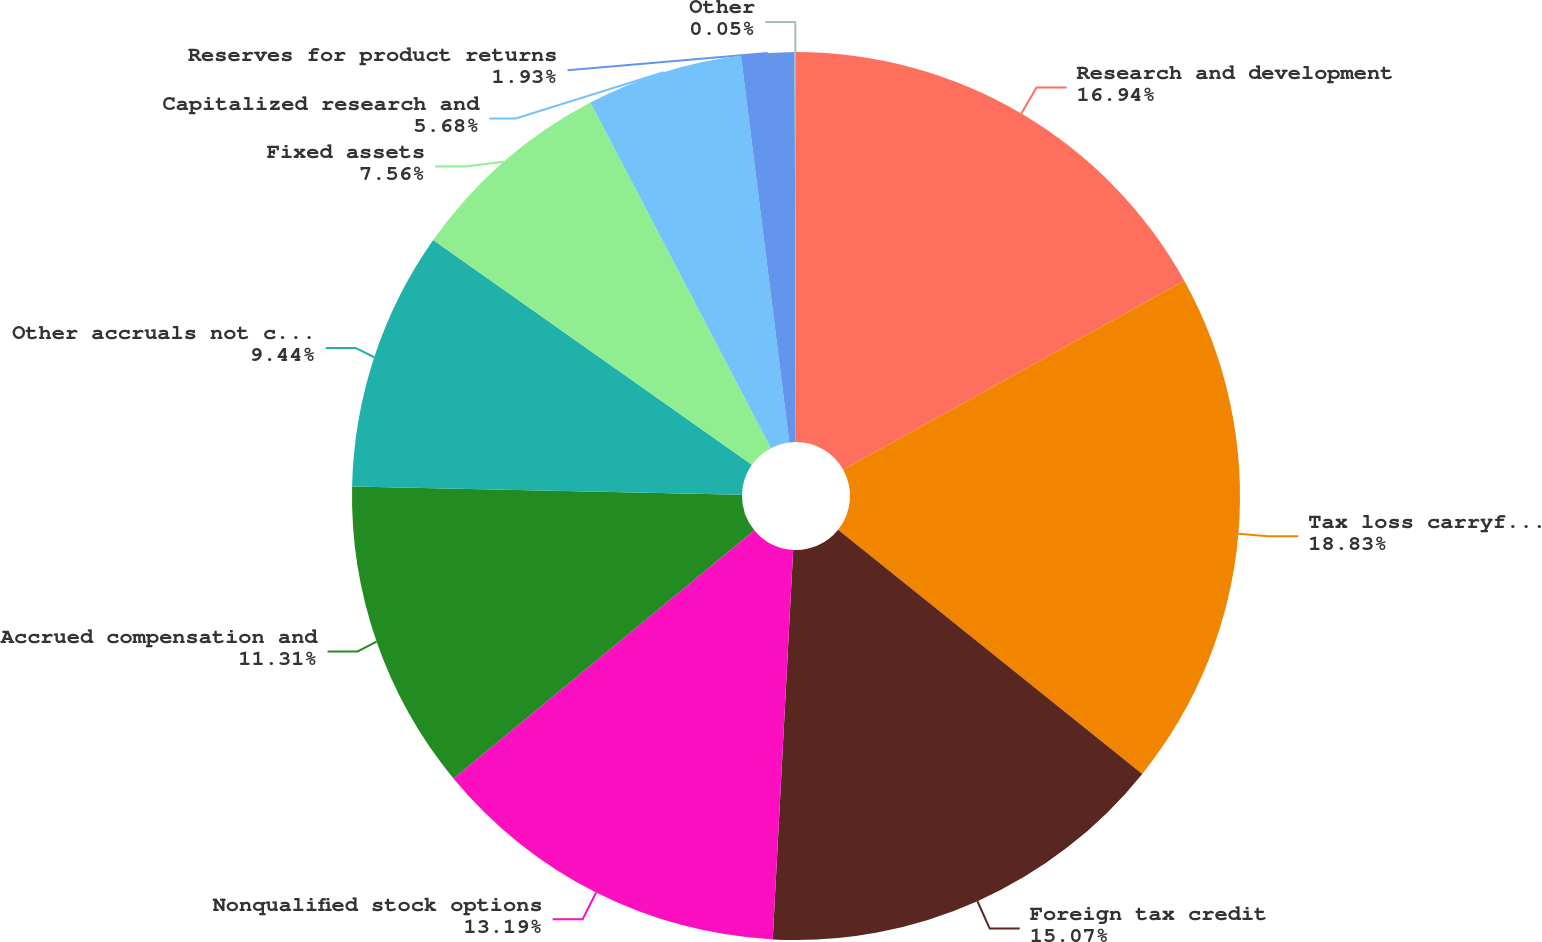Convert chart to OTSL. <chart><loc_0><loc_0><loc_500><loc_500><pie_chart><fcel>Research and development<fcel>Tax loss carryforwards<fcel>Foreign tax credit<fcel>Nonqualified stock options<fcel>Accrued compensation and<fcel>Other accruals not currently<fcel>Fixed assets<fcel>Capitalized research and<fcel>Reserves for product returns<fcel>Other<nl><fcel>16.94%<fcel>18.82%<fcel>15.07%<fcel>13.19%<fcel>11.31%<fcel>9.44%<fcel>7.56%<fcel>5.68%<fcel>1.93%<fcel>0.05%<nl></chart> 